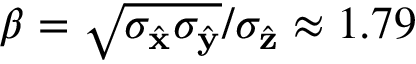Convert formula to latex. <formula><loc_0><loc_0><loc_500><loc_500>\beta = \sqrt { \sigma _ { \hat { x } } \sigma _ { \hat { y } } } / \sigma _ { \hat { z } } \approx 1 . 7 9</formula> 